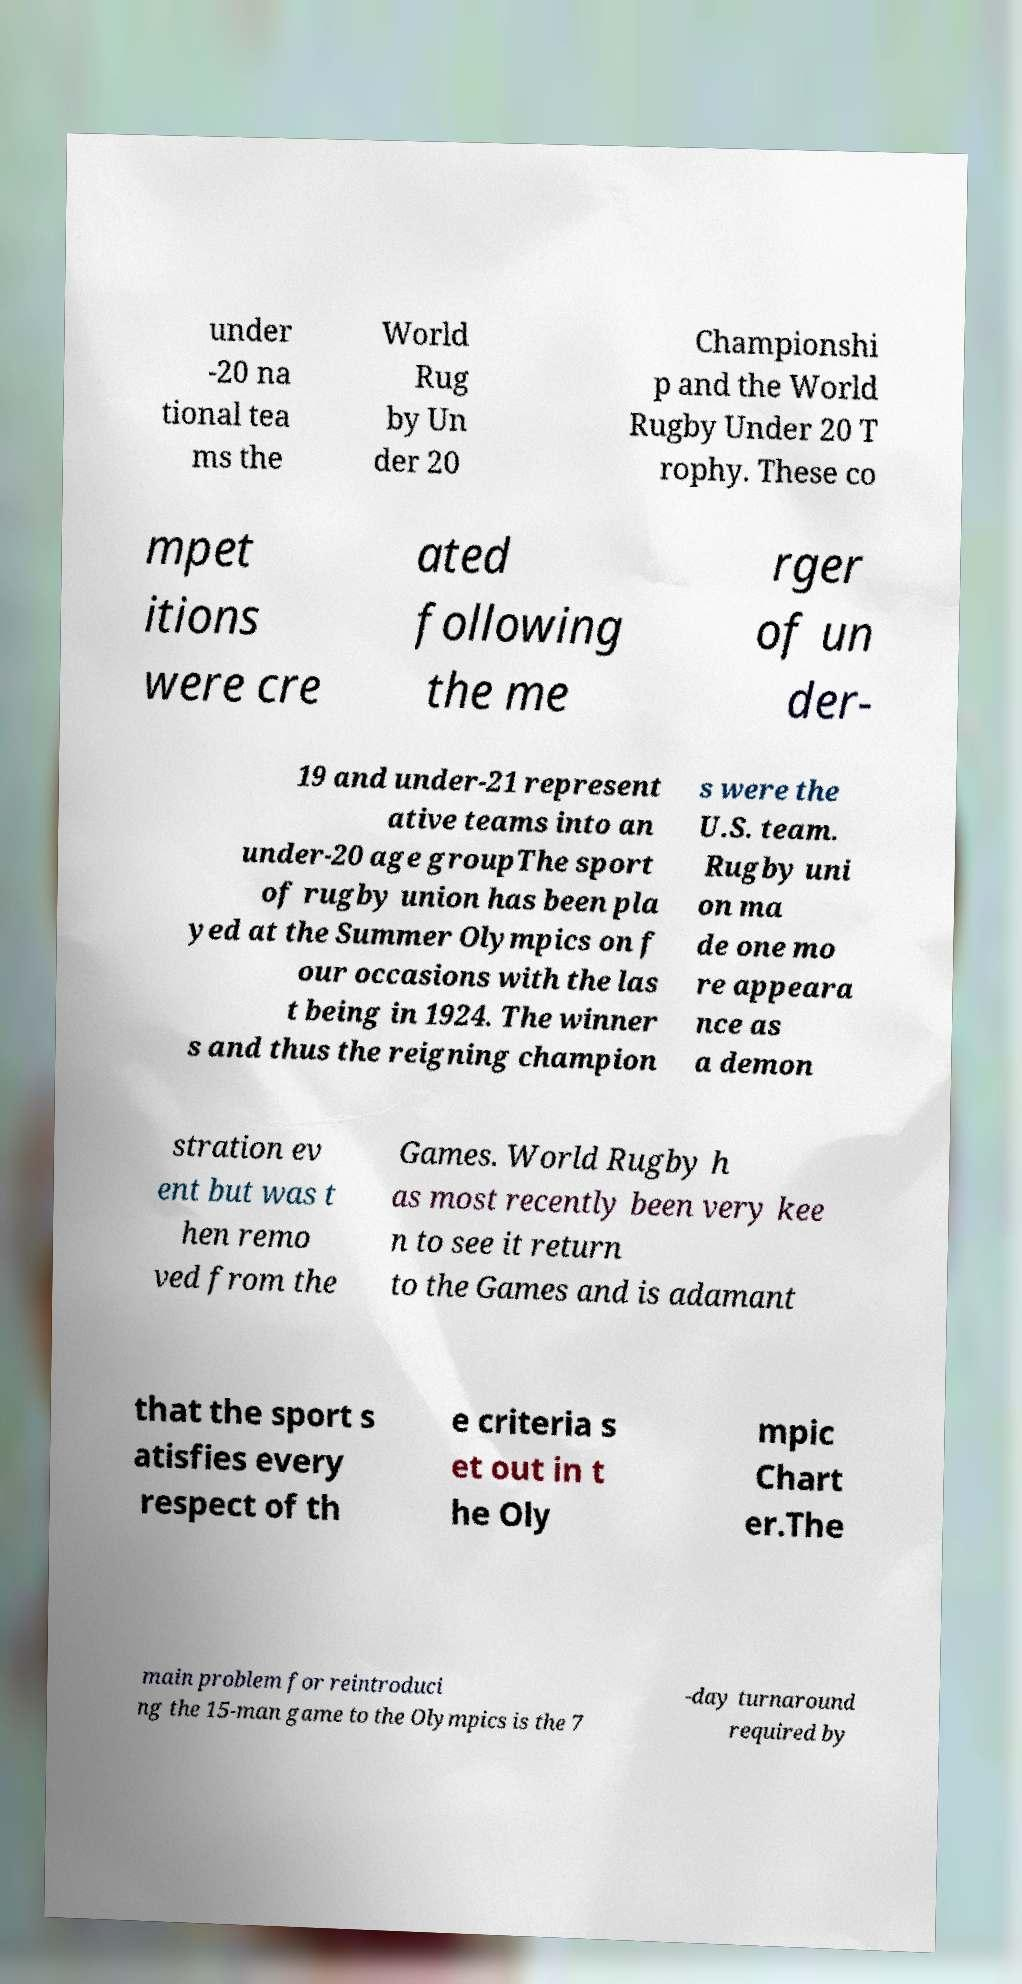What messages or text are displayed in this image? I need them in a readable, typed format. under -20 na tional tea ms the World Rug by Un der 20 Championshi p and the World Rugby Under 20 T rophy. These co mpet itions were cre ated following the me rger of un der- 19 and under-21 represent ative teams into an under-20 age groupThe sport of rugby union has been pla yed at the Summer Olympics on f our occasions with the las t being in 1924. The winner s and thus the reigning champion s were the U.S. team. Rugby uni on ma de one mo re appeara nce as a demon stration ev ent but was t hen remo ved from the Games. World Rugby h as most recently been very kee n to see it return to the Games and is adamant that the sport s atisfies every respect of th e criteria s et out in t he Oly mpic Chart er.The main problem for reintroduci ng the 15-man game to the Olympics is the 7 -day turnaround required by 